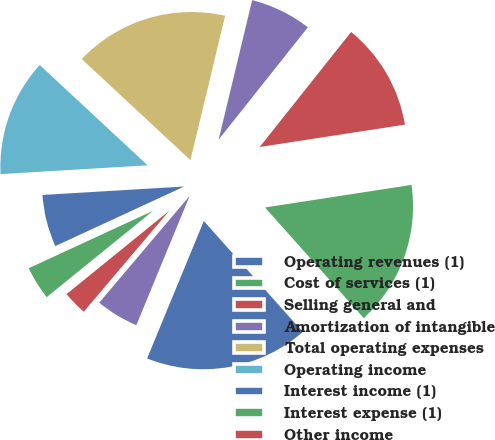Convert chart. <chart><loc_0><loc_0><loc_500><loc_500><pie_chart><fcel>Operating revenues (1)<fcel>Cost of services (1)<fcel>Selling general and<fcel>Amortization of intangible<fcel>Total operating expenses<fcel>Operating income<fcel>Interest income (1)<fcel>Interest expense (1)<fcel>Other income<fcel>Interest and other income net<nl><fcel>17.82%<fcel>15.84%<fcel>11.88%<fcel>6.93%<fcel>16.83%<fcel>12.87%<fcel>5.94%<fcel>3.96%<fcel>2.97%<fcel>4.95%<nl></chart> 